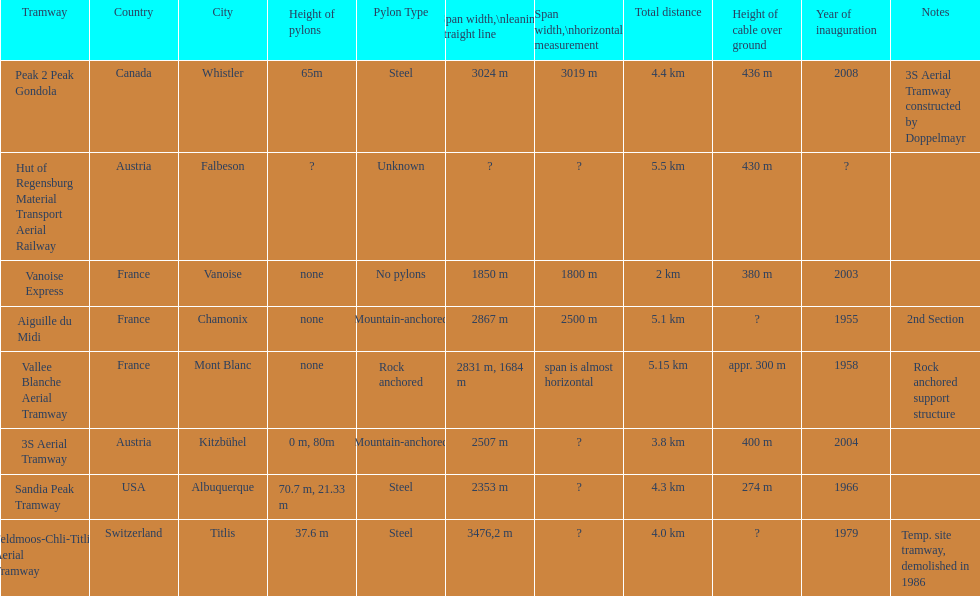Which tramway was inaugurated first, the 3s aerial tramway or the aiguille du midi? Aiguille du Midi. 